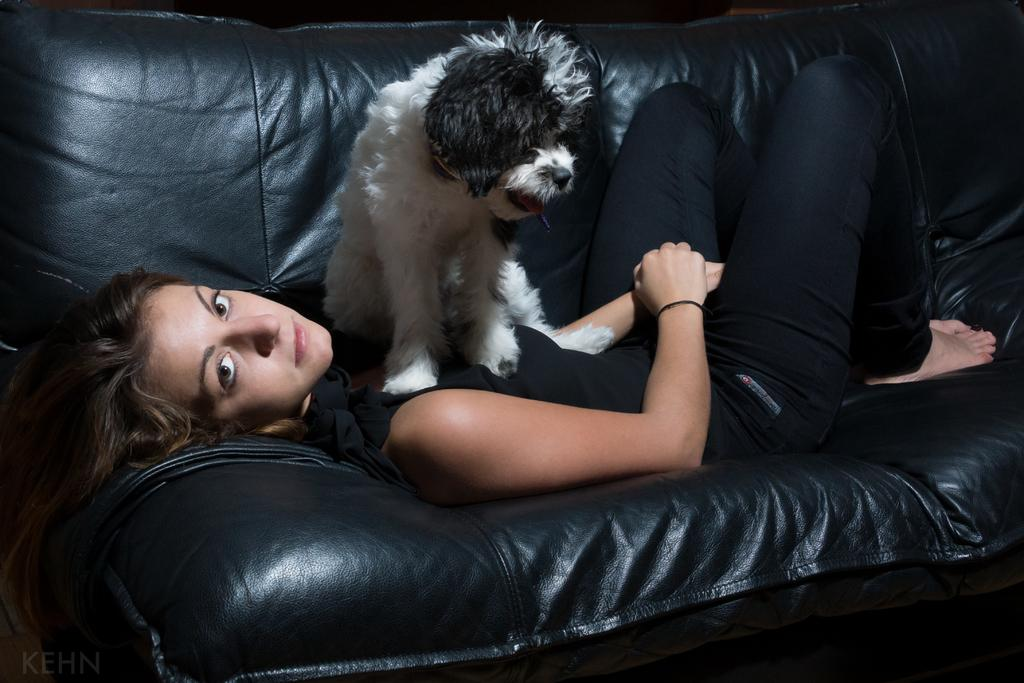Who is the main subject in the image? There is a woman in the image. What is the woman doing in the image? The woman is lying on a sofa. Is there any other living creature in the image besides the woman? Yes, there is a dog in the image. How is the dog positioned in relation to the woman? The dog is on the woman. Can you see any boys in the image? No, there are no boys present in the image. Is the woman touching the bushes in the image? There are no bushes present in the image, so it is not possible to determine if the woman is touching them. 